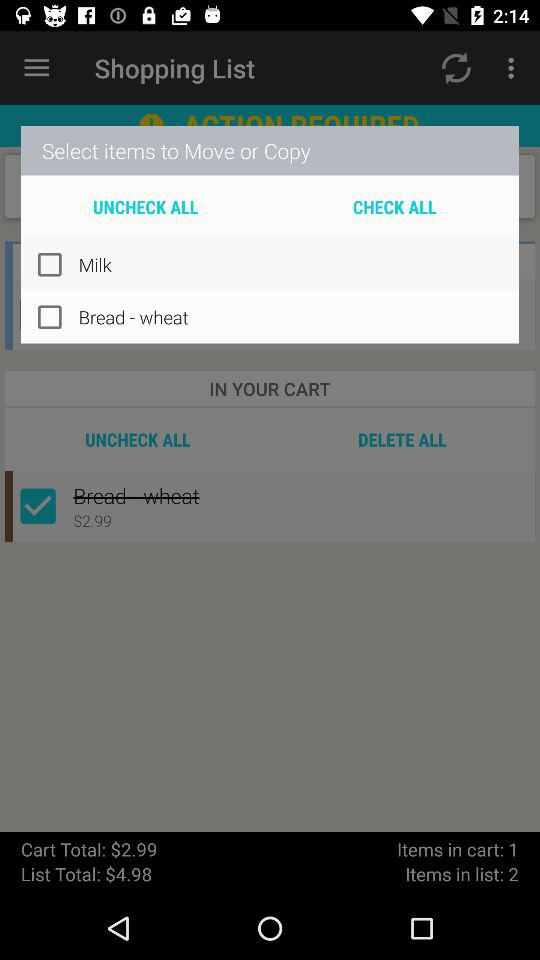What is the number of items in the list? The number of items in the list is 2. 